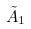Convert formula to latex. <formula><loc_0><loc_0><loc_500><loc_500>\tilde { A } _ { 1 }</formula> 